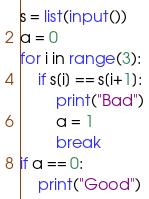Convert code to text. <code><loc_0><loc_0><loc_500><loc_500><_Python_>s = list(input())
a = 0
for i in range(3):
    if s[i] == s[i+1]:
        print("Bad")
        a = 1
        break
if a == 0:
    print("Good")</code> 